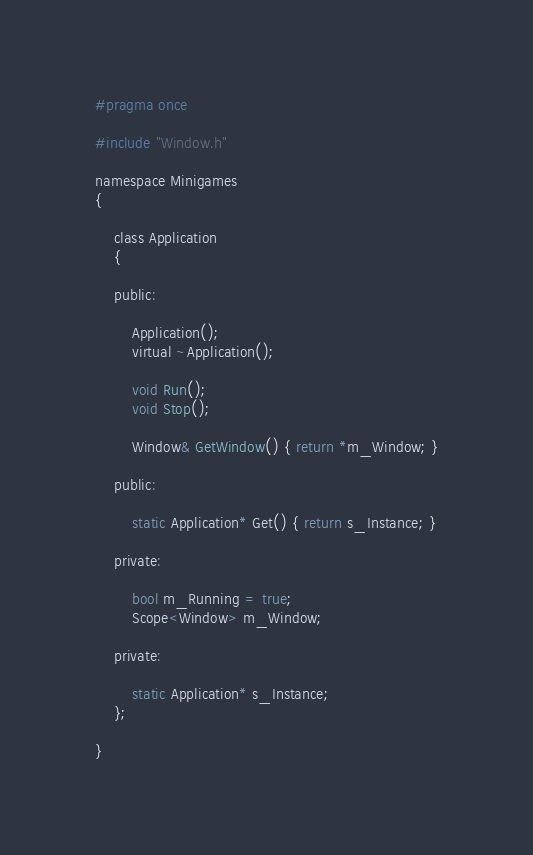<code> <loc_0><loc_0><loc_500><loc_500><_C_>#pragma once

#include "Window.h"

namespace Minigames
{

	class Application
	{

	public:

		Application();
		virtual ~Application();

		void Run();
		void Stop();

		Window& GetWindow() { return *m_Window; }

	public:

		static Application* Get() { return s_Instance; }

	private:

		bool m_Running = true;
		Scope<Window> m_Window;
	
	private:

		static Application* s_Instance;
	};

}</code> 